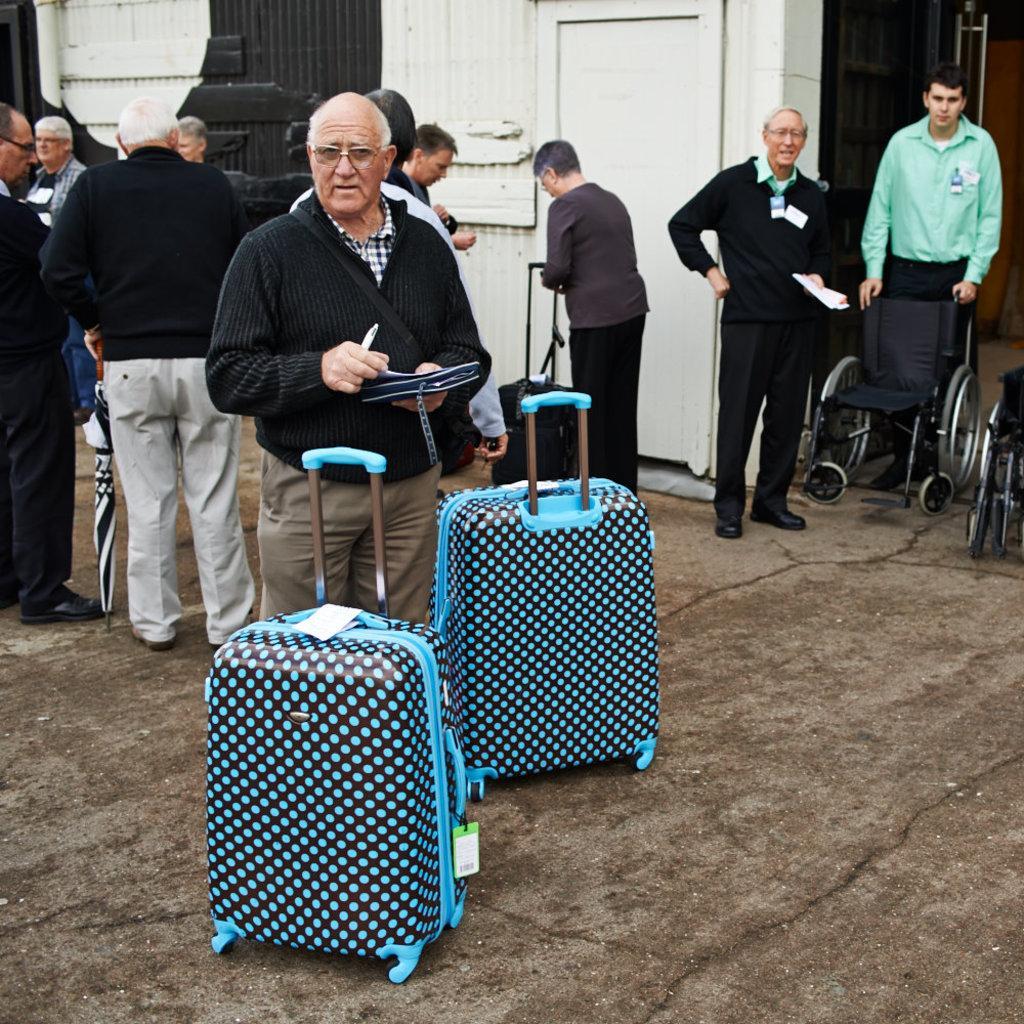Could you give a brief overview of what you see in this image? Here many men are standing. In the front there is a man with the black jacket. In front of them there are two blue color language bags. In the background there is a door and a building. To the right side there is a wheelchair. The man with green shirt is holding wheelchair. 